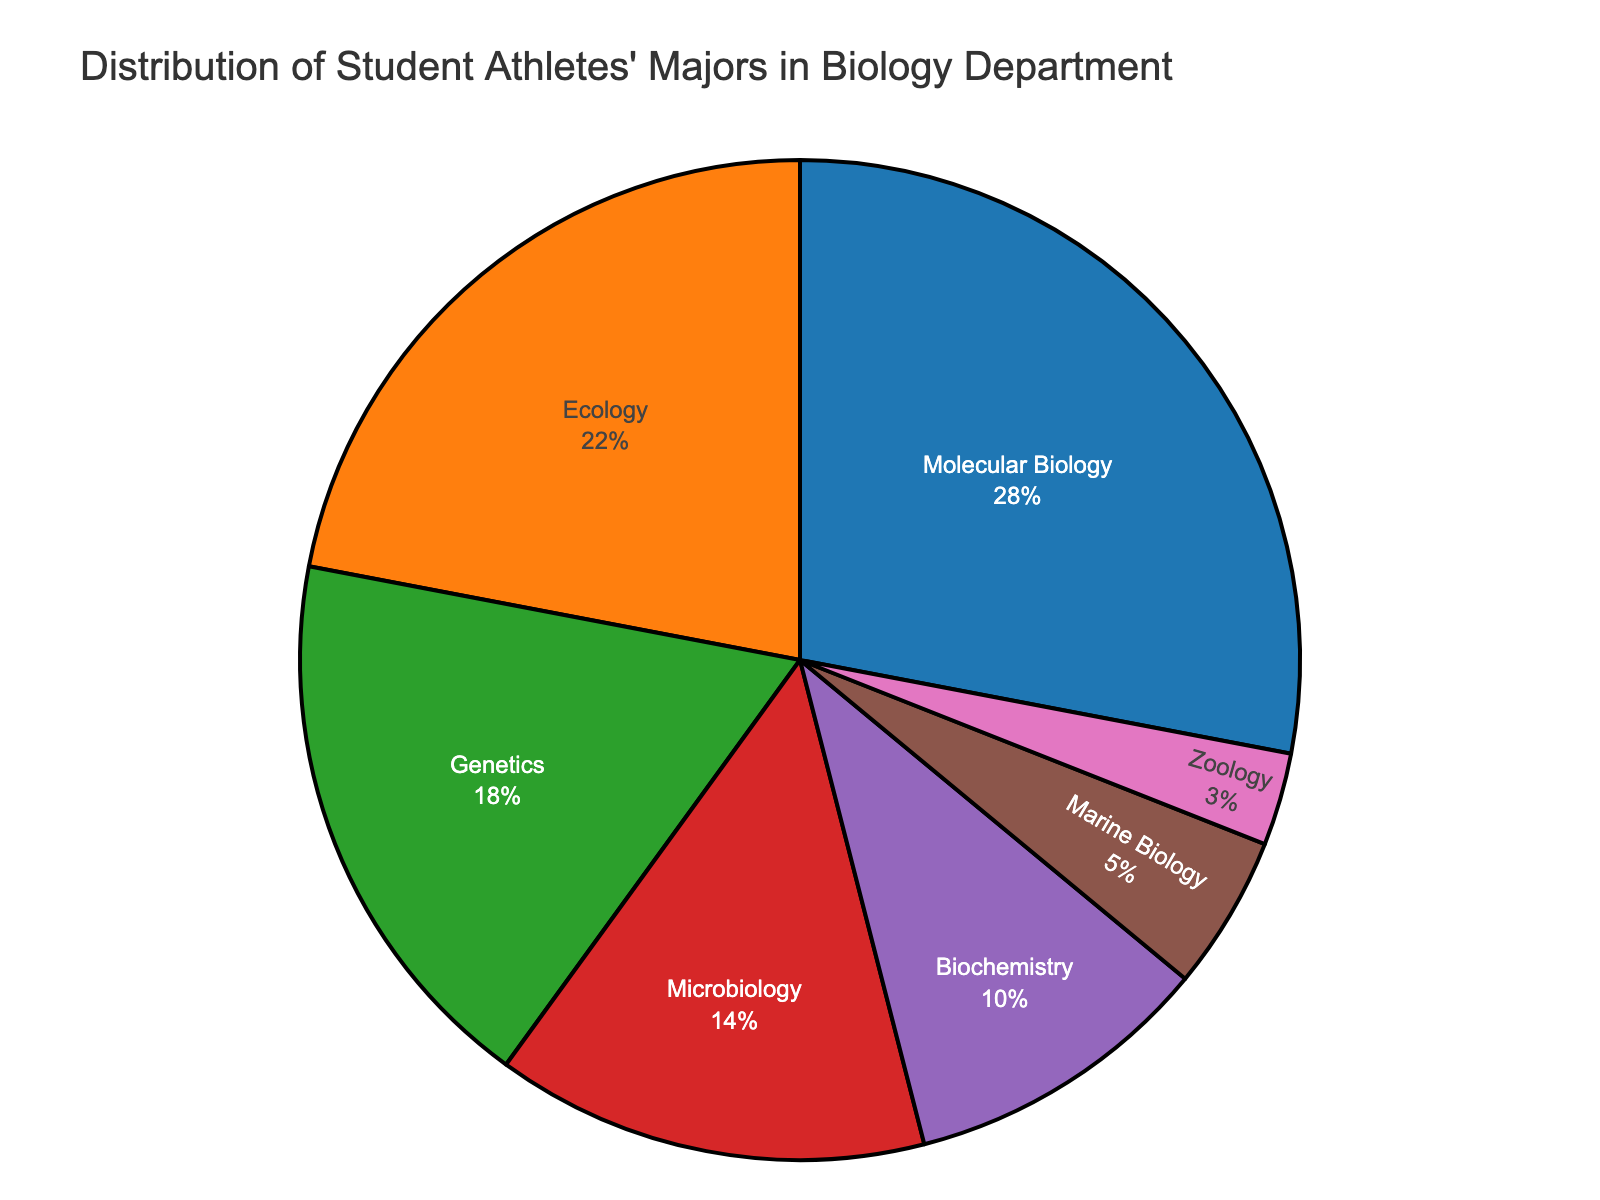Which major has the highest percentage of student athletes? To find the major with the highest percentage, we look at the pie chart and identify the segment that represents the largest portion. The largest segment corresponds to Molecular Biology with 28%.
Answer: Molecular Biology Which major has the lowest percentage of student athletes? To find the major with the lowest percentage, we look at the pie chart and identify the smallest segment. The smallest segment corresponds to Zoology with 3%.
Answer: Zoology What is the combined percentage of student athletes majoring in Molecular Biology and Ecology? We sum the percentages of the two majors: Molecular Biology (28%) + Ecology (22%) = 50%.
Answer: 50% How many more percentage points are student athletes majoring in Molecular Biology compared to student athletes majoring in Genetics? We subtract the percentage for Genetics from the percentage for Molecular Biology: 28% - 18% = 10%.
Answer: 10% Between Microbiology and Biochemistry, which major has a higher percentage of student athletes and by how much? We compare the percentages for Microbiology (14%) and Biochemistry (10%), and subtract the smaller from the larger: 14% - 10% = 4%.
Answer: Microbiology, by 4% What is the approximate average percentage of student athletes in the majors that have less than 10% representation? The majors with less than 10% are Marine Biology (5%) and Zoology (3%). The average is calculated by (5% + 3%) / 2 = 4%.
Answer: 4% Which color represents the major with the highest percentage of student athletes? Observing the pie chart's color legend and matching it with the highest percentage segment, we find Molecular Biology represented by a specific color.
Answer: Blue Visualize the percentage distribution in terms of quartiles. Which majors fall into the first quartile (from the 0% to the 25th percentile)? The first quartile includes all majors up to the 25th percentile. Since Marine Biology (5%) and Zoology (3%) cumulatively sum to 8%, both fall into the first quartile.
Answer: Marine Biology and Zoology Are there more student athletes in Microbiology than in Marine Biology and Zoology combined? We compare Microbiology's percentage (14%) with the combined percentage of Marine Biology (5%) and Zoology (3%): 5% + 3% = 8%. 14% > 8%, so yes.
Answer: Yes If we grouped Genetics and Microbiology together, what would their combined percentage be and how would it rank in comparison to other groups? We sum Genetics (18%) and Microbiology (14%): 18% + 14% = 32%. This combined group would have the highest percentage compared to the others.
Answer: 32%, highest 